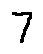<formula> <loc_0><loc_0><loc_500><loc_500>7</formula> 